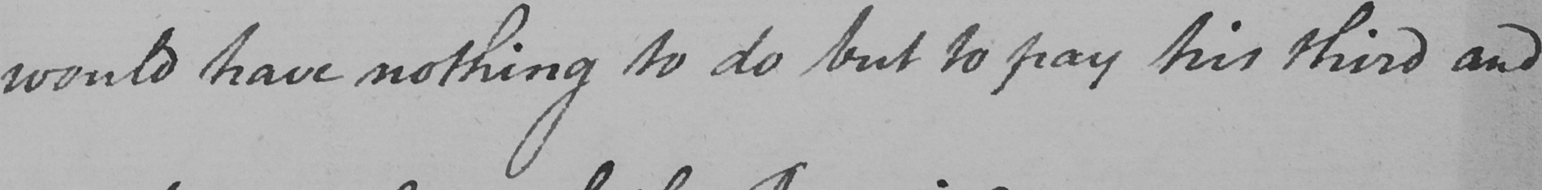What does this handwritten line say? would have nothing to do but to pay his third and 